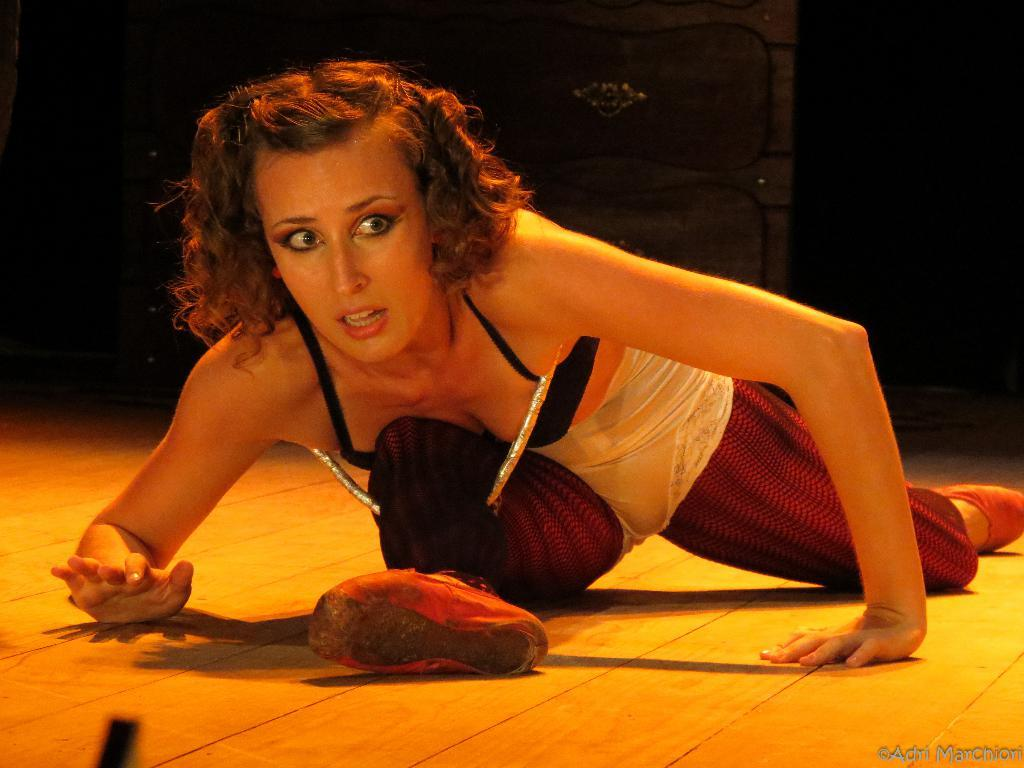Who is the main subject in the foreground of the image? There is a woman in the foreground of the image. Where is the woman located? The woman is on a stage. What can be observed about the background of the image? The background of the image is dark in color. Can we infer anything about the time of day based on the image? The image may have been taken during nighttime, given the dark background. What type of pipe is visible in the image? There is no pipe present in the image. How many leaves are on the ground in the image? There are no leaves visible in the image. 